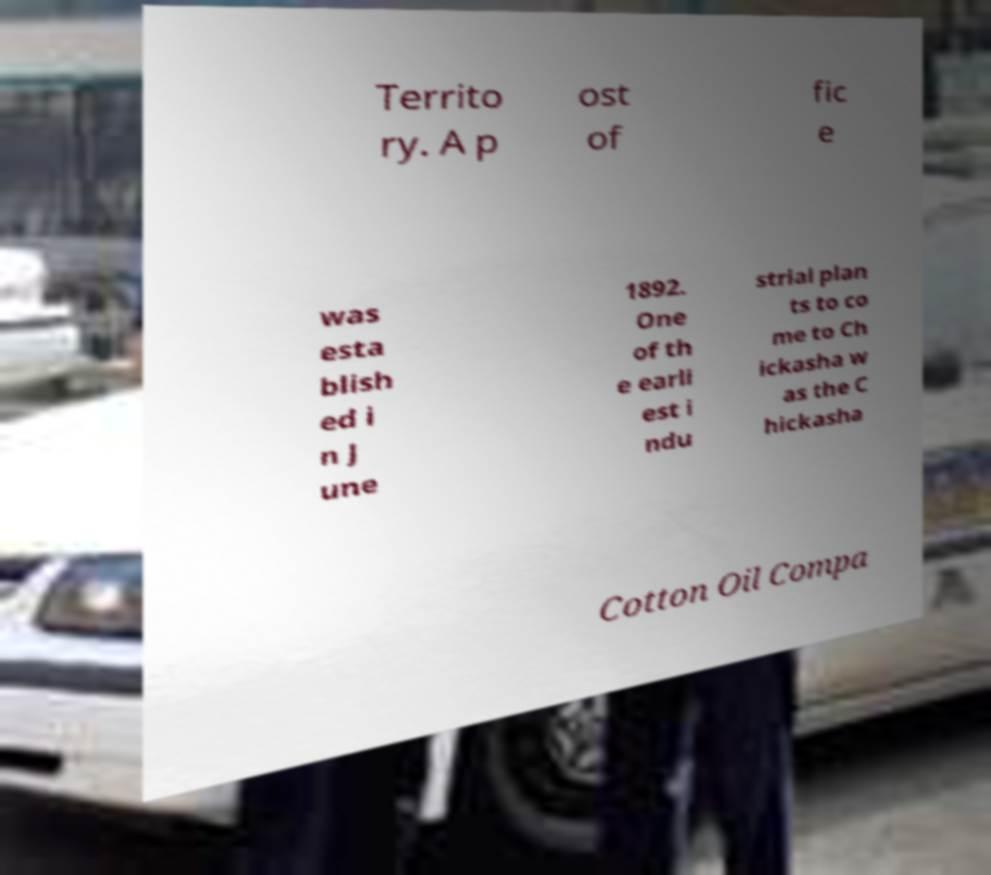Could you extract and type out the text from this image? Territo ry. A p ost of fic e was esta blish ed i n J une 1892. One of th e earli est i ndu strial plan ts to co me to Ch ickasha w as the C hickasha Cotton Oil Compa 